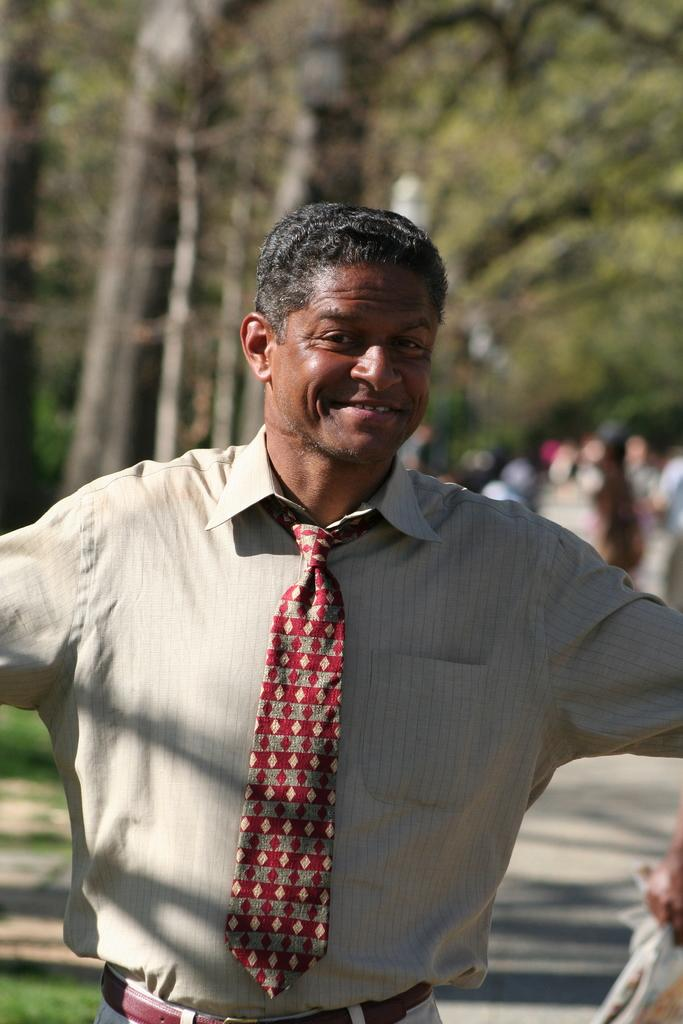Who is the main subject in the picture? There is a man in the picture. Where is the man located in the image? The man is in the middle of the picture. What is the man's facial expression in the image? The man is smiling. Can you describe the background of the image? The background of the image is blurred. What type of degree does the owl in the image have? There is no owl present in the image, so it is not possible to determine what type of degree it might have. 